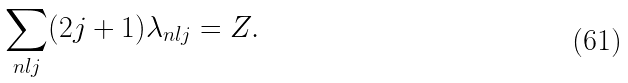<formula> <loc_0><loc_0><loc_500><loc_500>\sum _ { n l j } ( 2 j + 1 ) \lambda _ { n l j } = Z .</formula> 